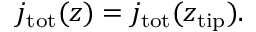<formula> <loc_0><loc_0><loc_500><loc_500>j _ { t o t } ( z ) = j _ { t o t } ( z _ { t i p } ) .</formula> 